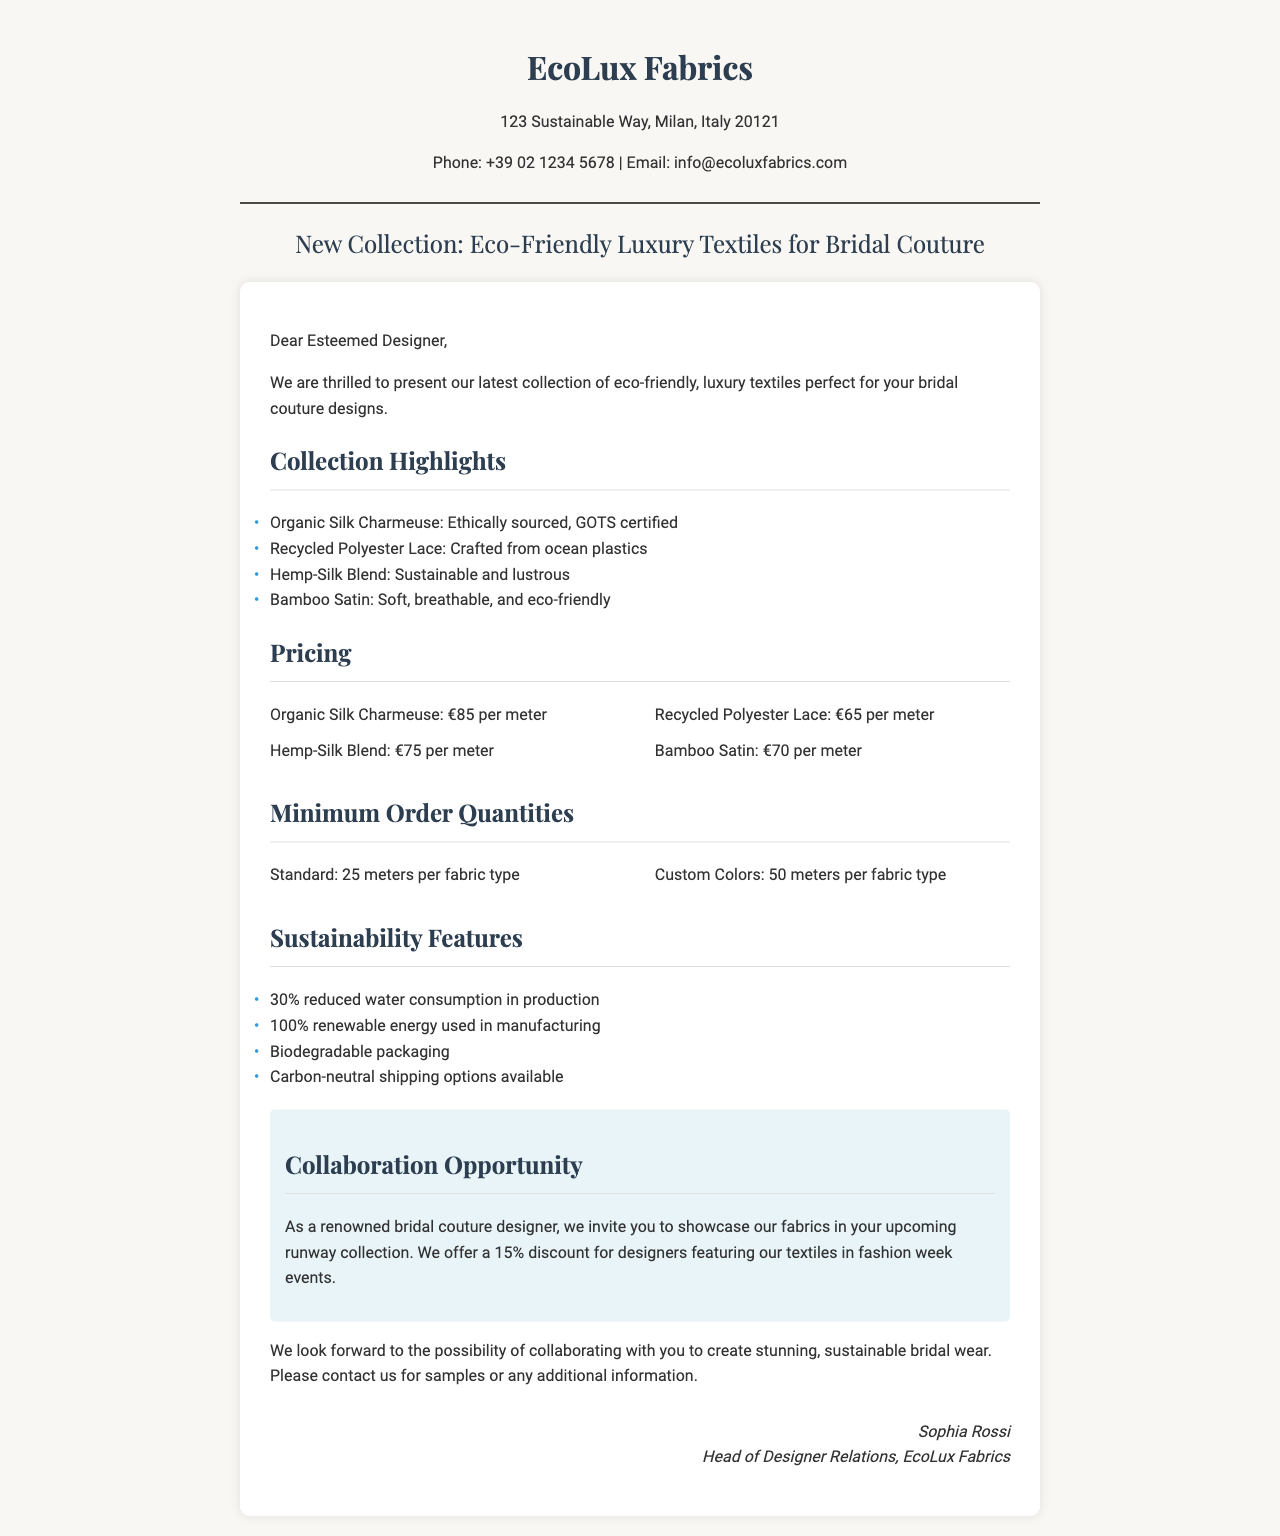what is the name of the fabric supplier? The name of the fabric supplier is highlighted at the top of the document.
Answer: EcoLux Fabrics what is the price of Organic Silk Charmeuse per meter? The pricing section lists various fabrics and their prices, including Organic Silk Charmeuse.
Answer: €85 per meter what is the minimum order quantity for custom colors? The minimum order quantities are specified for standard and custom orders.
Answer: 50 meters per fabric type which sustainable feature mentions reduced water consumption? The sustainability features list includes various eco-friendly aspects related to the fabrics.
Answer: 30% reduced water consumption in production what discount is offered for designers featuring textiles in fashion week events? The collaboration section outlines the discount provided for participating designers.
Answer: 15% discount how many eco-friendly textile types are highlighted in the collection? The collection highlights section lists distinct fabric types.
Answer: 4 types who is the contact person for designer relations? The signature section provides the name of the person responsible for designer relations.
Answer: Sophia Rossi which city is EcoLux Fabrics located in? The address at the top of the document specifies the city.
Answer: Milan 